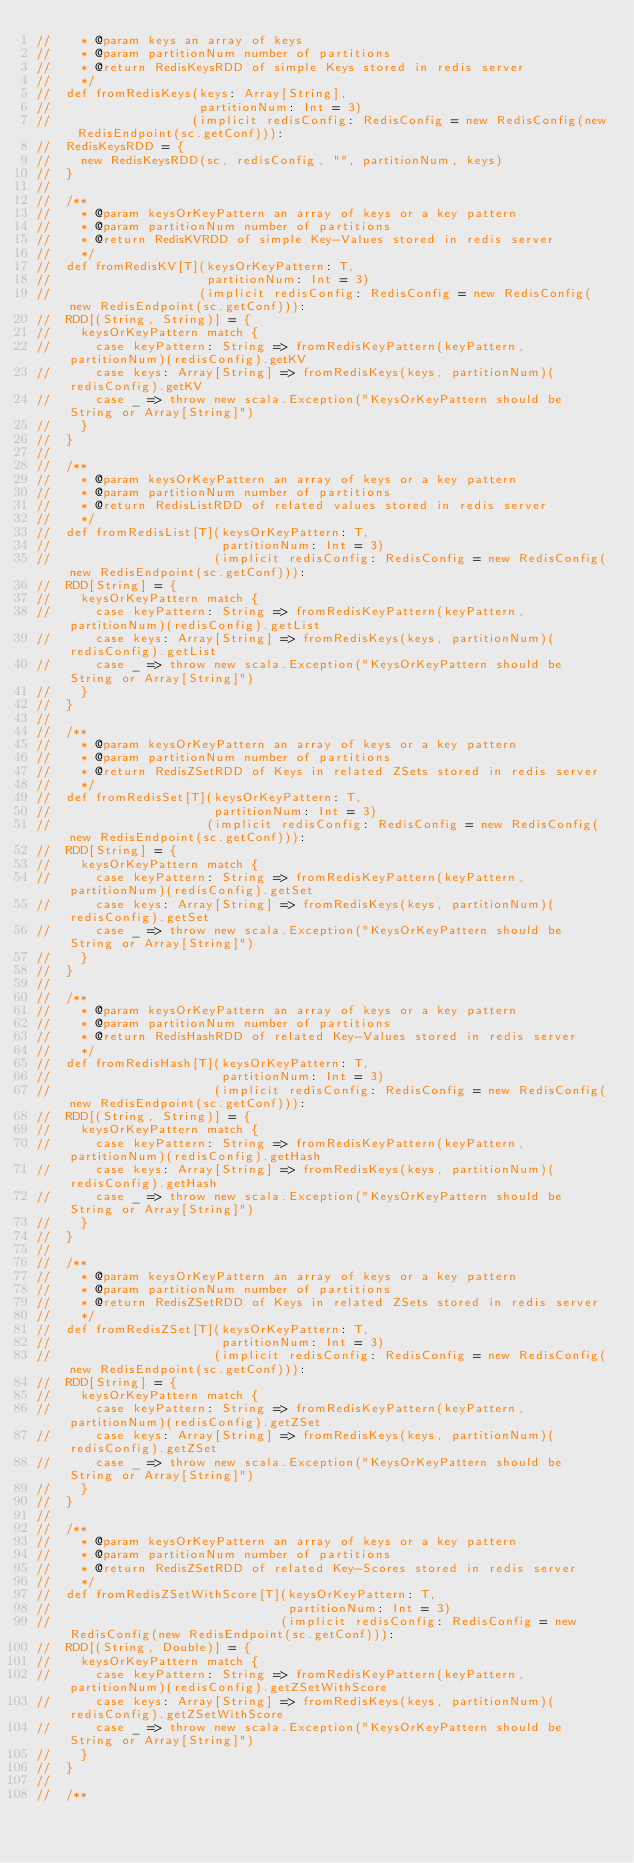Convert code to text. <code><loc_0><loc_0><loc_500><loc_500><_Scala_>//    * @param keys an array of keys
//    * @param partitionNum number of partitions
//    * @return RedisKeysRDD of simple Keys stored in redis server
//    */
//  def fromRedisKeys(keys: Array[String],
//                    partitionNum: Int = 3)
//                   (implicit redisConfig: RedisConfig = new RedisConfig(new RedisEndpoint(sc.getConf))):
//  RedisKeysRDD = {
//    new RedisKeysRDD(sc, redisConfig, "", partitionNum, keys)
//  }
//
//  /**
//    * @param keysOrKeyPattern an array of keys or a key pattern
//    * @param partitionNum number of partitions
//    * @return RedisKVRDD of simple Key-Values stored in redis server
//    */
//  def fromRedisKV[T](keysOrKeyPattern: T,
//                     partitionNum: Int = 3)
//                    (implicit redisConfig: RedisConfig = new RedisConfig(new RedisEndpoint(sc.getConf))):
//  RDD[(String, String)] = {
//    keysOrKeyPattern match {
//      case keyPattern: String => fromRedisKeyPattern(keyPattern, partitionNum)(redisConfig).getKV
//      case keys: Array[String] => fromRedisKeys(keys, partitionNum)(redisConfig).getKV
//      case _ => throw new scala.Exception("KeysOrKeyPattern should be String or Array[String]")
//    }
//  }
//
//  /**
//    * @param keysOrKeyPattern an array of keys or a key pattern
//    * @param partitionNum number of partitions
//    * @return RedisListRDD of related values stored in redis server
//    */
//  def fromRedisList[T](keysOrKeyPattern: T,
//                       partitionNum: Int = 3)
//                      (implicit redisConfig: RedisConfig = new RedisConfig(new RedisEndpoint(sc.getConf))):
//  RDD[String] = {
//    keysOrKeyPattern match {
//      case keyPattern: String => fromRedisKeyPattern(keyPattern, partitionNum)(redisConfig).getList
//      case keys: Array[String] => fromRedisKeys(keys, partitionNum)(redisConfig).getList
//      case _ => throw new scala.Exception("KeysOrKeyPattern should be String or Array[String]")
//    }
//  }
//
//  /**
//    * @param keysOrKeyPattern an array of keys or a key pattern
//    * @param partitionNum number of partitions
//    * @return RedisZSetRDD of Keys in related ZSets stored in redis server
//    */
//  def fromRedisSet[T](keysOrKeyPattern: T,
//                      partitionNum: Int = 3)
//                     (implicit redisConfig: RedisConfig = new RedisConfig(new RedisEndpoint(sc.getConf))):
//  RDD[String] = {
//    keysOrKeyPattern match {
//      case keyPattern: String => fromRedisKeyPattern(keyPattern, partitionNum)(redisConfig).getSet
//      case keys: Array[String] => fromRedisKeys(keys, partitionNum)(redisConfig).getSet
//      case _ => throw new scala.Exception("KeysOrKeyPattern should be String or Array[String]")
//    }
//  }
//
//  /**
//    * @param keysOrKeyPattern an array of keys or a key pattern
//    * @param partitionNum number of partitions
//    * @return RedisHashRDD of related Key-Values stored in redis server
//    */
//  def fromRedisHash[T](keysOrKeyPattern: T,
//                       partitionNum: Int = 3)
//                      (implicit redisConfig: RedisConfig = new RedisConfig(new RedisEndpoint(sc.getConf))):
//  RDD[(String, String)] = {
//    keysOrKeyPattern match {
//      case keyPattern: String => fromRedisKeyPattern(keyPattern, partitionNum)(redisConfig).getHash
//      case keys: Array[String] => fromRedisKeys(keys, partitionNum)(redisConfig).getHash
//      case _ => throw new scala.Exception("KeysOrKeyPattern should be String or Array[String]")
//    }
//  }
//
//  /**
//    * @param keysOrKeyPattern an array of keys or a key pattern
//    * @param partitionNum number of partitions
//    * @return RedisZSetRDD of Keys in related ZSets stored in redis server
//    */
//  def fromRedisZSet[T](keysOrKeyPattern: T,
//                       partitionNum: Int = 3)
//                      (implicit redisConfig: RedisConfig = new RedisConfig(new RedisEndpoint(sc.getConf))):
//  RDD[String] = {
//    keysOrKeyPattern match {
//      case keyPattern: String => fromRedisKeyPattern(keyPattern, partitionNum)(redisConfig).getZSet
//      case keys: Array[String] => fromRedisKeys(keys, partitionNum)(redisConfig).getZSet
//      case _ => throw new scala.Exception("KeysOrKeyPattern should be String or Array[String]")
//    }
//  }
//
//  /**
//    * @param keysOrKeyPattern an array of keys or a key pattern
//    * @param partitionNum number of partitions
//    * @return RedisZSetRDD of related Key-Scores stored in redis server
//    */
//  def fromRedisZSetWithScore[T](keysOrKeyPattern: T,
//                                partitionNum: Int = 3)
//                               (implicit redisConfig: RedisConfig = new RedisConfig(new RedisEndpoint(sc.getConf))):
//  RDD[(String, Double)] = {
//    keysOrKeyPattern match {
//      case keyPattern: String => fromRedisKeyPattern(keyPattern, partitionNum)(redisConfig).getZSetWithScore
//      case keys: Array[String] => fromRedisKeys(keys, partitionNum)(redisConfig).getZSetWithScore
//      case _ => throw new scala.Exception("KeysOrKeyPattern should be String or Array[String]")
//    }
//  }
//
//  /**</code> 